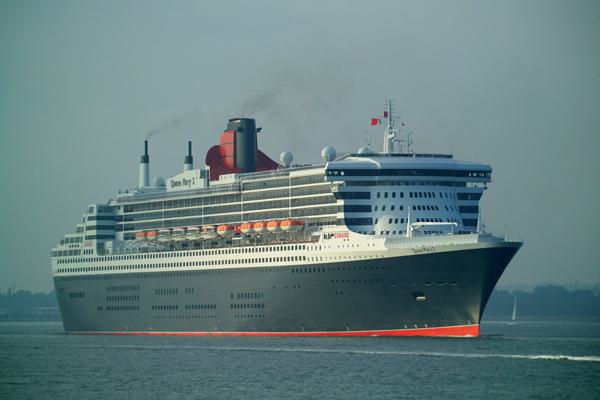Can you estimate how many decks this ship has? Based on the visible rows of windows and the structure of the ship, it appears that the ship may have around 13 or 14 passenger decks, which is common for a cruise ship of this size. 